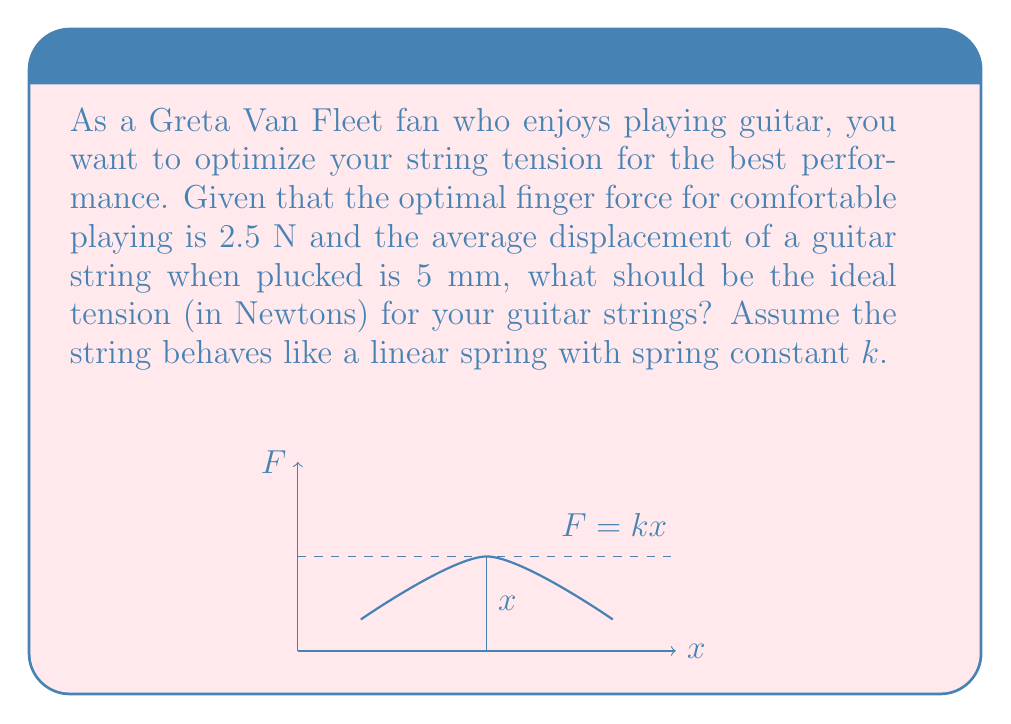What is the answer to this math problem? Let's approach this step-by-step using biomechanical principles:

1) In a linear spring system, force (F) is related to displacement (x) by Hooke's Law:

   $$F = kx$$

   where $k$ is the spring constant.

2) We're given:
   - Optimal finger force (F) = 2.5 N
   - Average displacement (x) = 5 mm = 0.005 m

3) To find the ideal tension, we need to calculate the spring constant $k$:

   $$k = \frac{F}{x} = \frac{2.5 \text{ N}}{0.005 \text{ m}} = 500 \text{ N/m}$$

4) The tension (T) in a string is related to the spring constant by:

   $$T = kL$$

   where L is the length of the string.

5) A typical electric guitar string length is about 65 cm or 0.65 m.

6) Therefore, the ideal tension is:

   $$T = kL = 500 \text{ N/m} \times 0.65 \text{ m} = 325 \text{ N}$$

This tension will provide the optimal balance between playability and tone for your guitar performance.
Answer: 325 N 